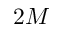Convert formula to latex. <formula><loc_0><loc_0><loc_500><loc_500>2 M</formula> 